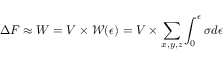<formula> <loc_0><loc_0><loc_500><loc_500>\Delta F \approx W = V \times \mathcal { W } ( \epsilon ) = V \times \sum _ { x , y , z } \int _ { 0 } ^ { \epsilon } \sigma d \epsilon</formula> 